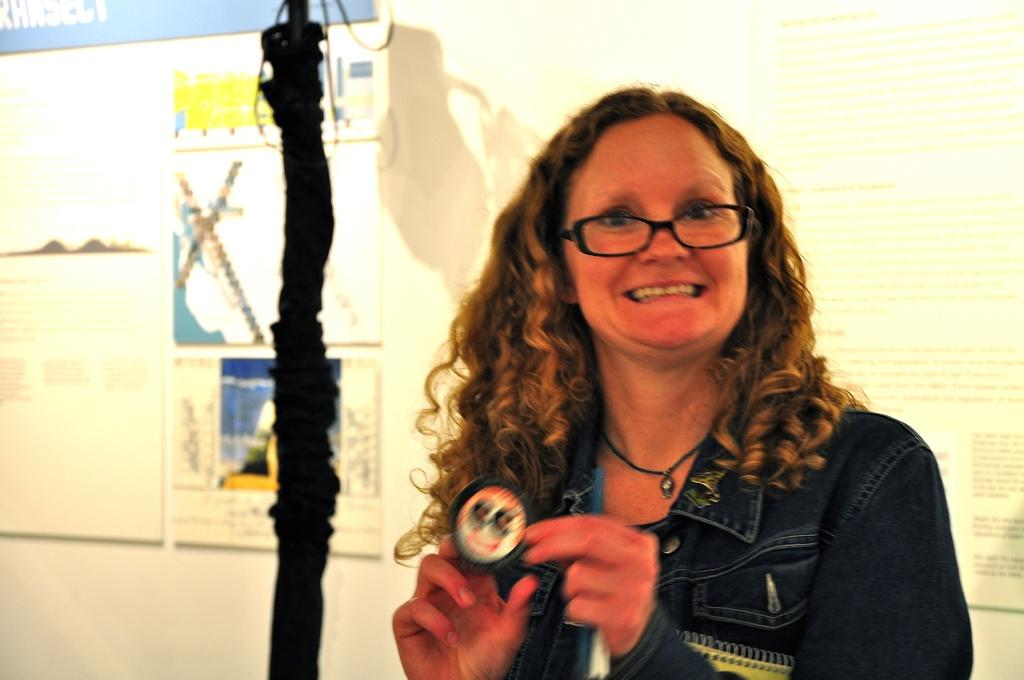What is the main subject of the image? There is a person standing in the image. What is the person holding in the image? The person is holding an object. Can you describe any other objects or features in the image? There is a rod beside the person, and there are posters on the wall in the background of the image. What type of sense does the hospital manager have in the image? There is no hospital or manager present in the image, so it is not possible to determine what type of sense they might have. 